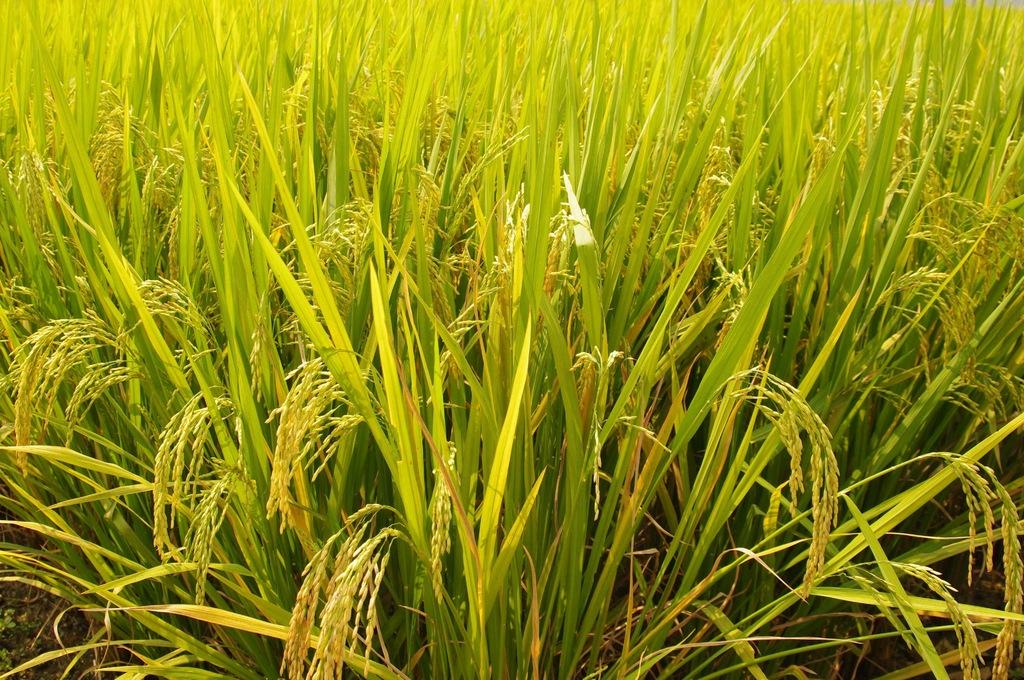What type of living organisms can be seen in the image? Plants can be seen in the image. What colors are present in the plants? The plants have green, brown, and yellow colors. What type of sweater are the children wearing in the image? There are no children or sweaters present in the image; it only features plants. 